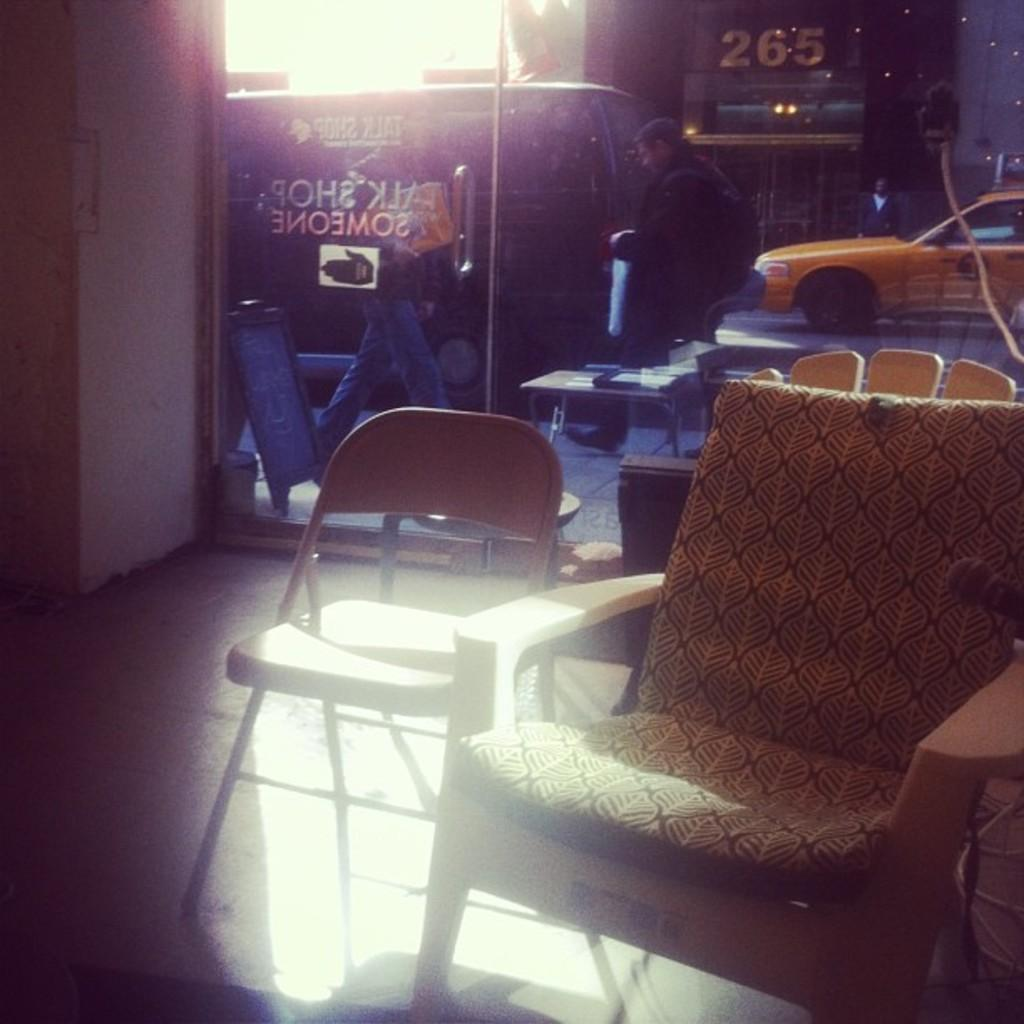What objects are present in the image that are not occupied? There are empty chairs in the image. What type of glass element is visible in the image? There is a glass element in the image. What can be seen through the glass? A car is visible through the glass. What activity is happening in the image involving people and the glass? People are walking through the glass. What type of establishment is depicted in the image? The image depicts a store. Can you see any snails crawling on the glass in the image? There are no snails visible in the image. What type of potato is being used as a decoration in the store? There is no potato present in the image; it depicts a store with chairs, a glass element, a car, and people walking through the glass. 